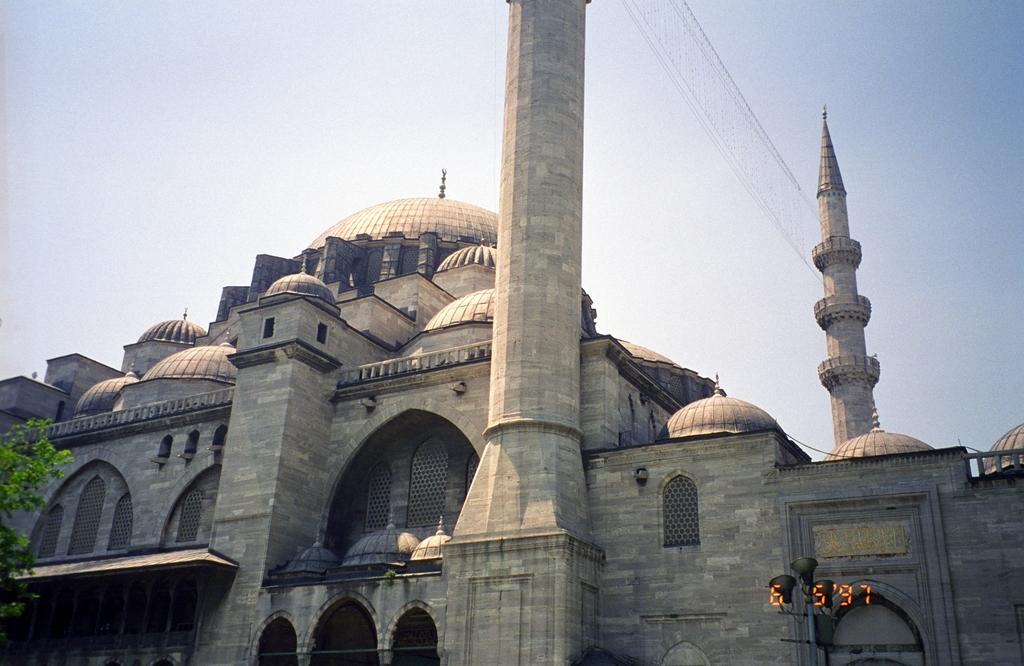What type of structure is in the image? There is a building in the image. What are some features of the building? The building has walls, windows, arches, and pillars. Where can leaves be found in the image? The leaves are in the left corner of the image. What is visible at the top of the image? The sky is visible at the top of the image. What type of holiday is being celebrated in the image? There is no indication of a holiday being celebrated in the image. What pump-related activity is happening in the image? There is no pump present in the image, so no pump-related activity can be observed. 